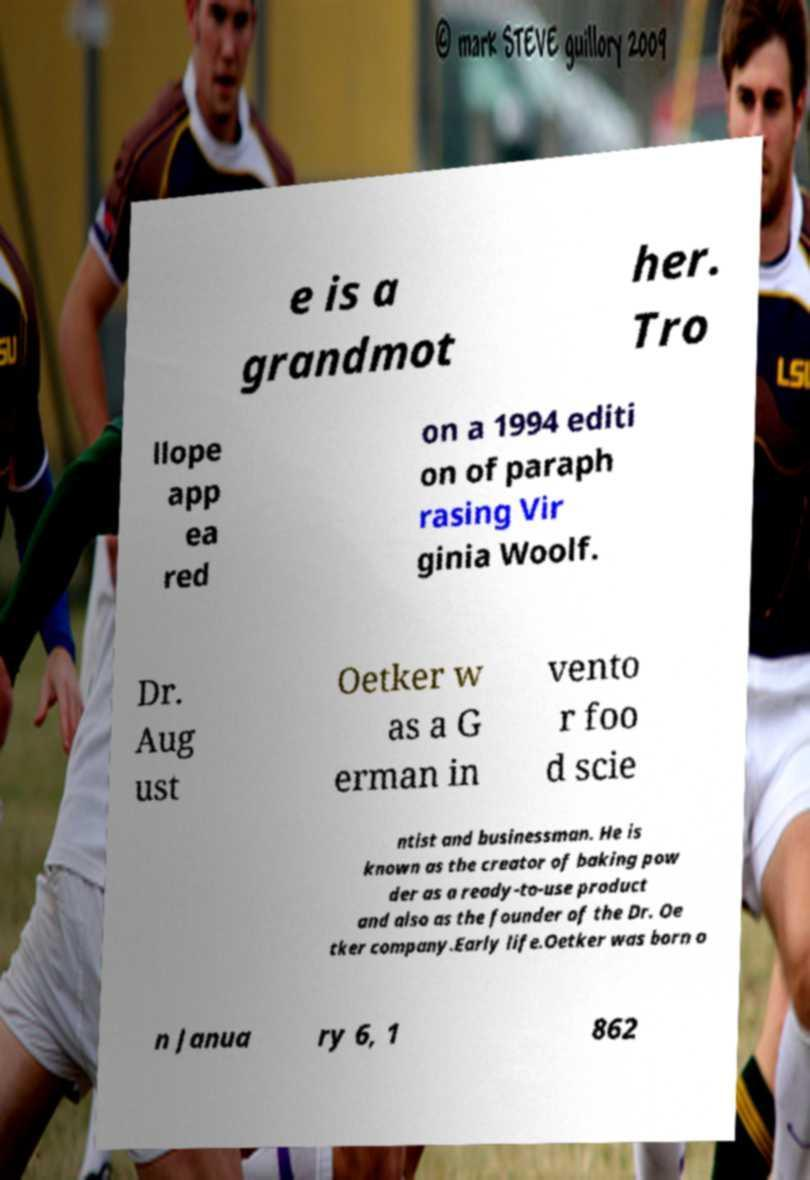Could you extract and type out the text from this image? e is a grandmot her. Tro llope app ea red on a 1994 editi on of paraph rasing Vir ginia Woolf. Dr. Aug ust Oetker w as a G erman in vento r foo d scie ntist and businessman. He is known as the creator of baking pow der as a ready-to-use product and also as the founder of the Dr. Oe tker company.Early life.Oetker was born o n Janua ry 6, 1 862 